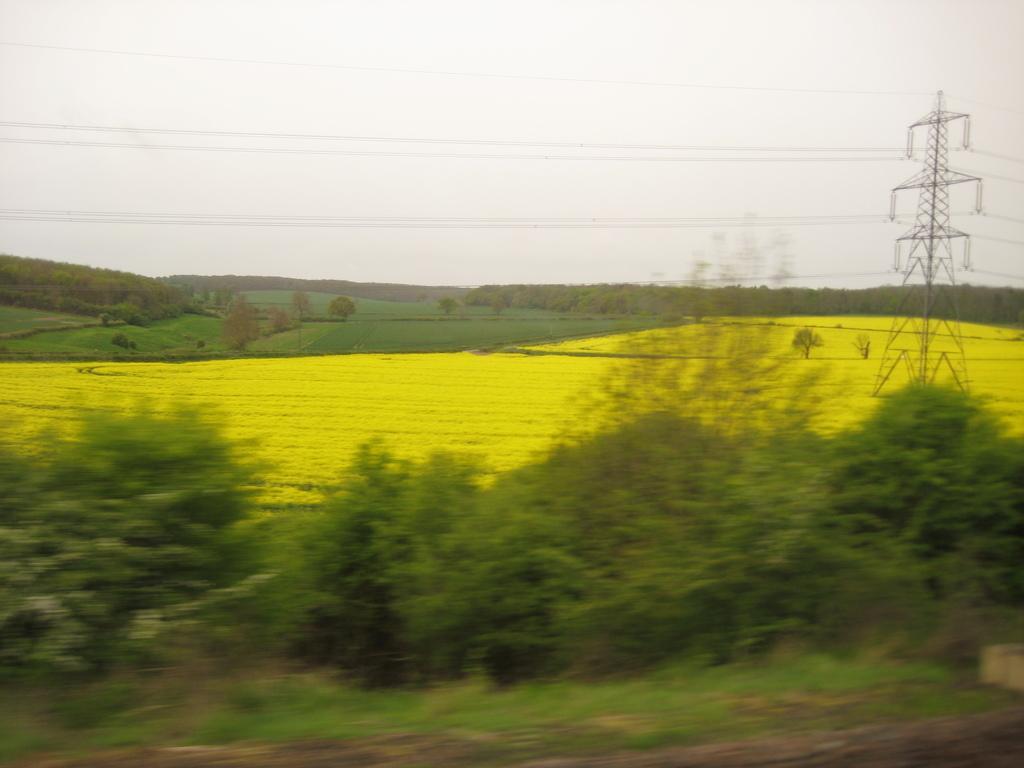Can you describe this image briefly? In this image I can see there are trees at the bottom, in the middle there are crops. On the right side there is an electric pole, at the top it is the sky. 